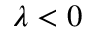<formula> <loc_0><loc_0><loc_500><loc_500>\lambda < 0</formula> 